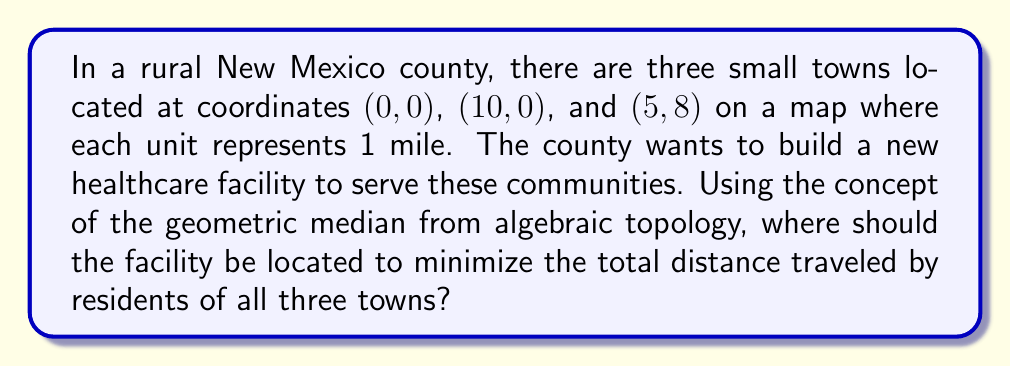Give your solution to this math problem. Let's approach this step-by-step:

1) The geometric median is a point that minimizes the sum of distances to a given set of points. In this case, we're looking for a point $(x,y)$ that minimizes the total distance to the three towns.

2) Let's define the function we want to minimize:

   $$f(x,y) = \sqrt{x^2 + y^2} + \sqrt{(x-10)^2 + y^2} + \sqrt{(x-5)^2 + (y-8)^2}$$

3) To find the minimum, we need to solve:

   $$\frac{\partial f}{\partial x} = 0 \quad \text{and} \quad \frac{\partial f}{\partial y} = 0$$

4) However, these equations are complex and don't have a simple algebraic solution. In practice, numerical methods are used to solve this problem.

5) One method is the Weiszfeld algorithm, an iterative process:

   $$x_{n+1} = \frac{\sum_{i=1}^3 \frac{x_i}{d_i}}{\sum_{i=1}^3 \frac{1}{d_i}} \quad \text{and} \quad y_{n+1} = \frac{\sum_{i=1}^3 \frac{y_i}{d_i}}{\sum_{i=1}^3 \frac{1}{d_i}}$$

   Where $(x_i, y_i)$ are the coordinates of the towns and $d_i$ is the distance from the current point to town $i$.

6) Starting with an initial guess (e.g., the centroid of the triangle formed by the towns), we can iterate until the change becomes negligibly small.

7) After several iterations, the algorithm converges to approximately $(4.78, 2.96)$.

This point minimizes the total distance traveled by residents of all three towns to reach the healthcare facility.
Answer: $(4.78, 2.96)$ 